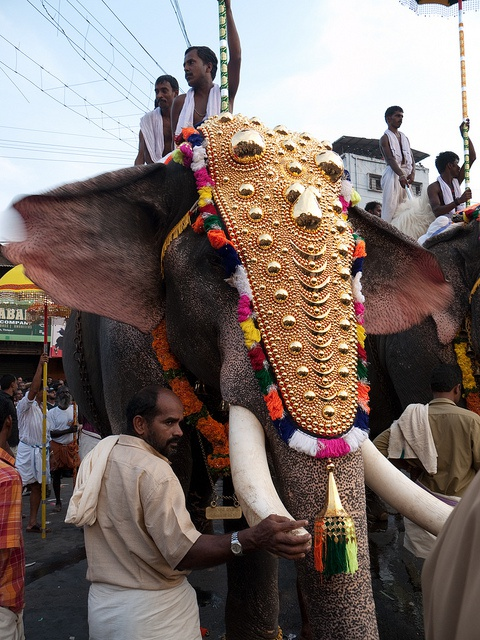Describe the objects in this image and their specific colors. I can see elephant in lightblue, black, maroon, ivory, and brown tones, people in lightblue, black, darkgray, and gray tones, people in lightblue, black, gray, and maroon tones, elephant in lightblue, black, maroon, brown, and gray tones, and people in lightblue, gray, and black tones in this image. 